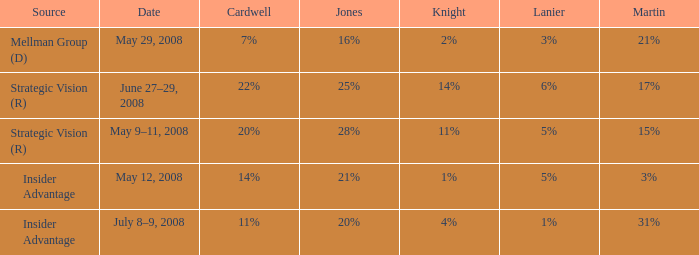What Lanier has a Cardwell of 20%? 5%. 